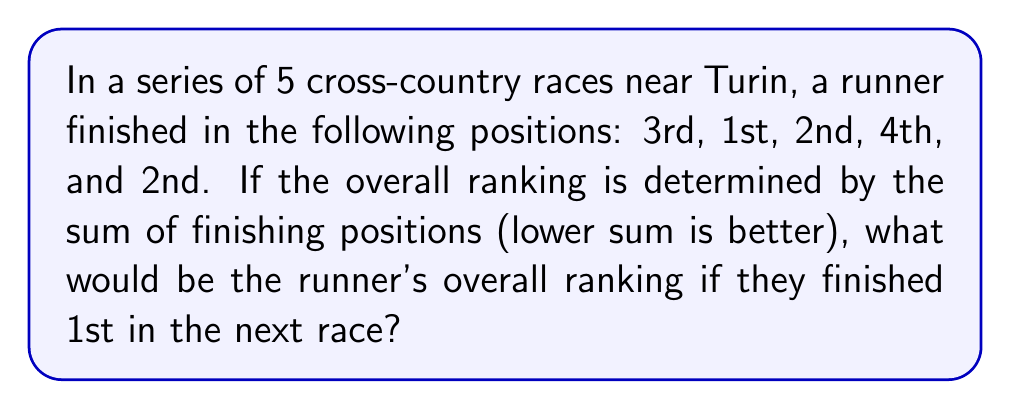Show me your answer to this math problem. To solve this problem, we'll follow these steps:

1. Calculate the current sum of finishing positions:
   $3 + 1 + 2 + 4 + 2 = 12$

2. Add the hypothetical 1st place finish to the sum:
   $12 + 1 = 13$

3. Calculate the average finishing position:
   $$\text{Average} = \frac{\text{Sum of positions}}{\text{Number of races}} = \frac{13}{6} \approx 2.17$$

The overall ranking is determined by this average, where a lower average is better. The average of 2.17 means that, on average, the runner finished between 2nd and 3rd place across all races.

To express this as an overall ranking, we round the average to the nearest whole number:

$$\text{Overall ranking} = \text{round}(2.17) = 2$$

Therefore, the runner's overall ranking after the hypothetical 6th race would be 2nd place.
Answer: 2nd place 